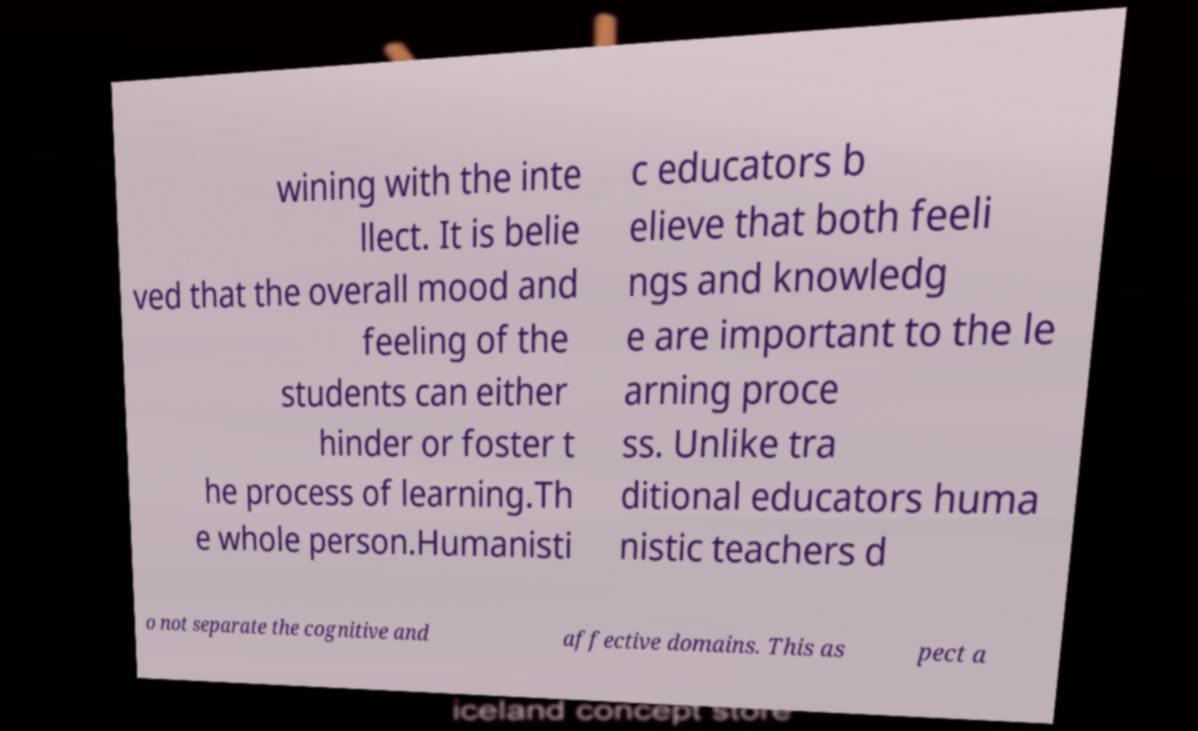Could you extract and type out the text from this image? wining with the inte llect. It is belie ved that the overall mood and feeling of the students can either hinder or foster t he process of learning.Th e whole person.Humanisti c educators b elieve that both feeli ngs and knowledg e are important to the le arning proce ss. Unlike tra ditional educators huma nistic teachers d o not separate the cognitive and affective domains. This as pect a 